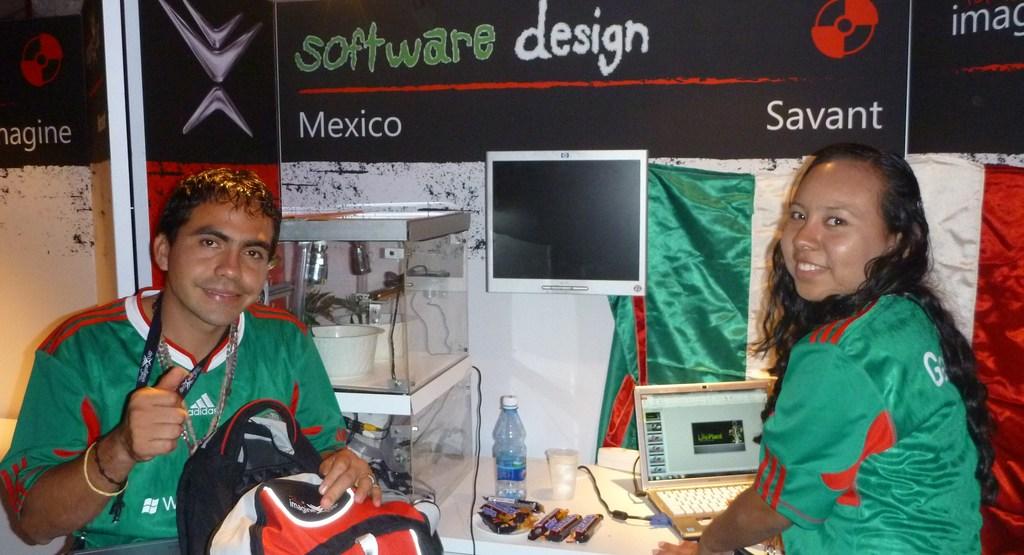What country is mentioned below the red line?
Your answer should be compact. Mexico. What kind of design is being spoken of>?
Your answer should be very brief. Software. 